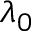<formula> <loc_0><loc_0><loc_500><loc_500>\lambda _ { 0 }</formula> 